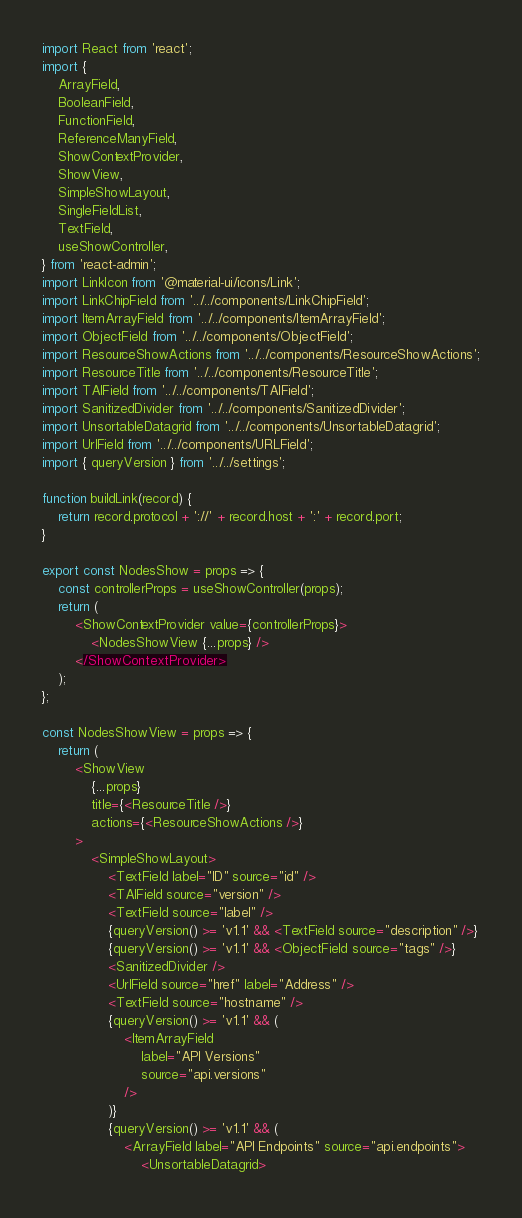Convert code to text. <code><loc_0><loc_0><loc_500><loc_500><_JavaScript_>import React from 'react';
import {
    ArrayField,
    BooleanField,
    FunctionField,
    ReferenceManyField,
    ShowContextProvider,
    ShowView,
    SimpleShowLayout,
    SingleFieldList,
    TextField,
    useShowController,
} from 'react-admin';
import LinkIcon from '@material-ui/icons/Link';
import LinkChipField from '../../components/LinkChipField';
import ItemArrayField from '../../components/ItemArrayField';
import ObjectField from '../../components/ObjectField';
import ResourceShowActions from '../../components/ResourceShowActions';
import ResourceTitle from '../../components/ResourceTitle';
import TAIField from '../../components/TAIField';
import SanitizedDivider from '../../components/SanitizedDivider';
import UnsortableDatagrid from '../../components/UnsortableDatagrid';
import UrlField from '../../components/URLField';
import { queryVersion } from '../../settings';

function buildLink(record) {
    return record.protocol + '://' + record.host + ':' + record.port;
}

export const NodesShow = props => {
    const controllerProps = useShowController(props);
    return (
        <ShowContextProvider value={controllerProps}>
            <NodesShowView {...props} />
        </ShowContextProvider>
    );
};

const NodesShowView = props => {
    return (
        <ShowView
            {...props}
            title={<ResourceTitle />}
            actions={<ResourceShowActions />}
        >
            <SimpleShowLayout>
                <TextField label="ID" source="id" />
                <TAIField source="version" />
                <TextField source="label" />
                {queryVersion() >= 'v1.1' && <TextField source="description" />}
                {queryVersion() >= 'v1.1' && <ObjectField source="tags" />}
                <SanitizedDivider />
                <UrlField source="href" label="Address" />
                <TextField source="hostname" />
                {queryVersion() >= 'v1.1' && (
                    <ItemArrayField
                        label="API Versions"
                        source="api.versions"
                    />
                )}
                {queryVersion() >= 'v1.1' && (
                    <ArrayField label="API Endpoints" source="api.endpoints">
                        <UnsortableDatagrid></code> 